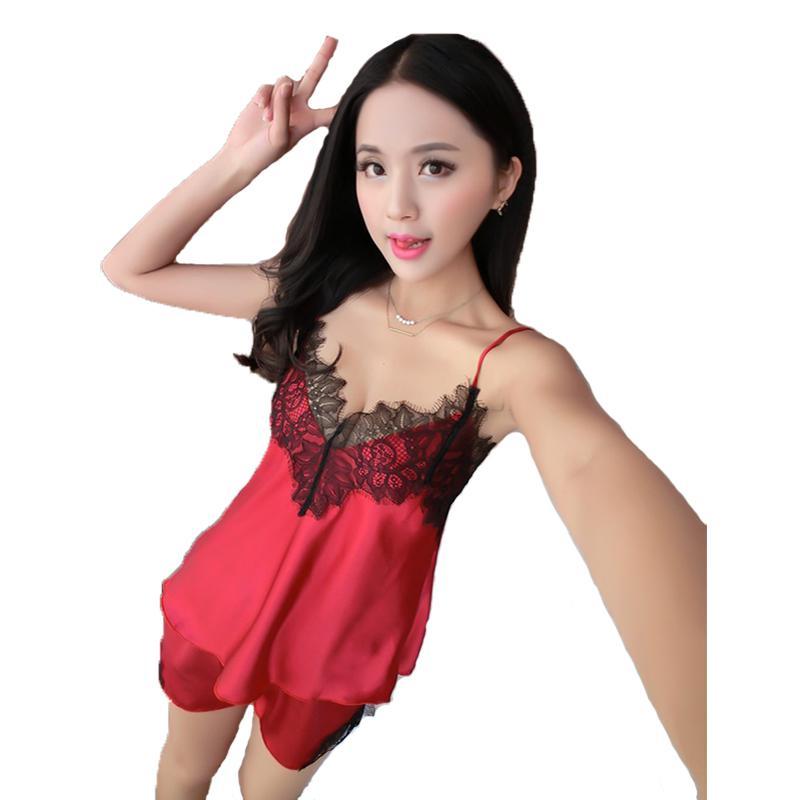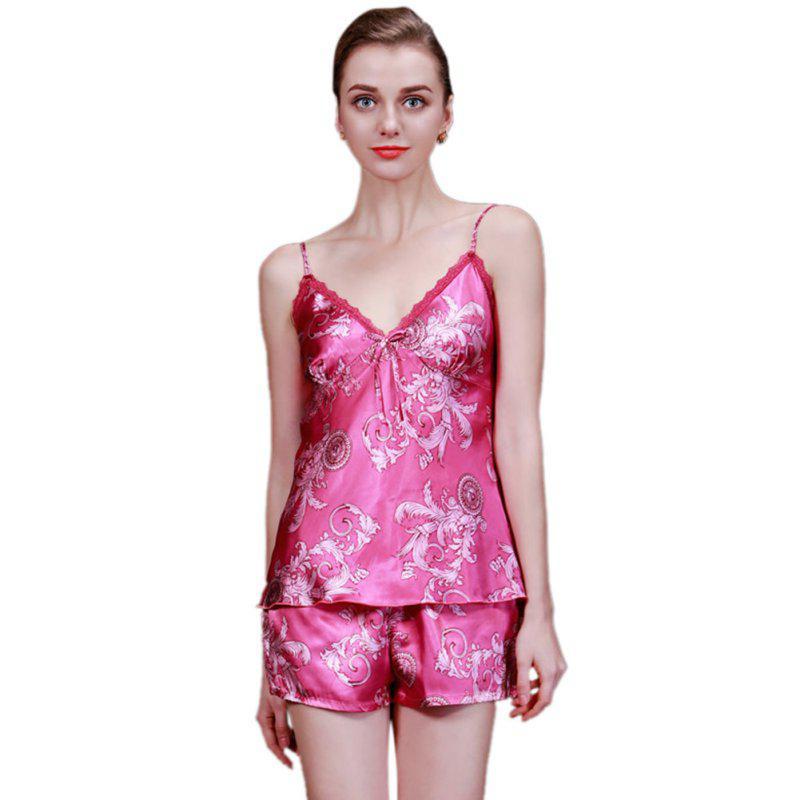The first image is the image on the left, the second image is the image on the right. Analyze the images presented: Is the assertion "there is a silky cami set with white lace on the chest" valid? Answer yes or no. No. 